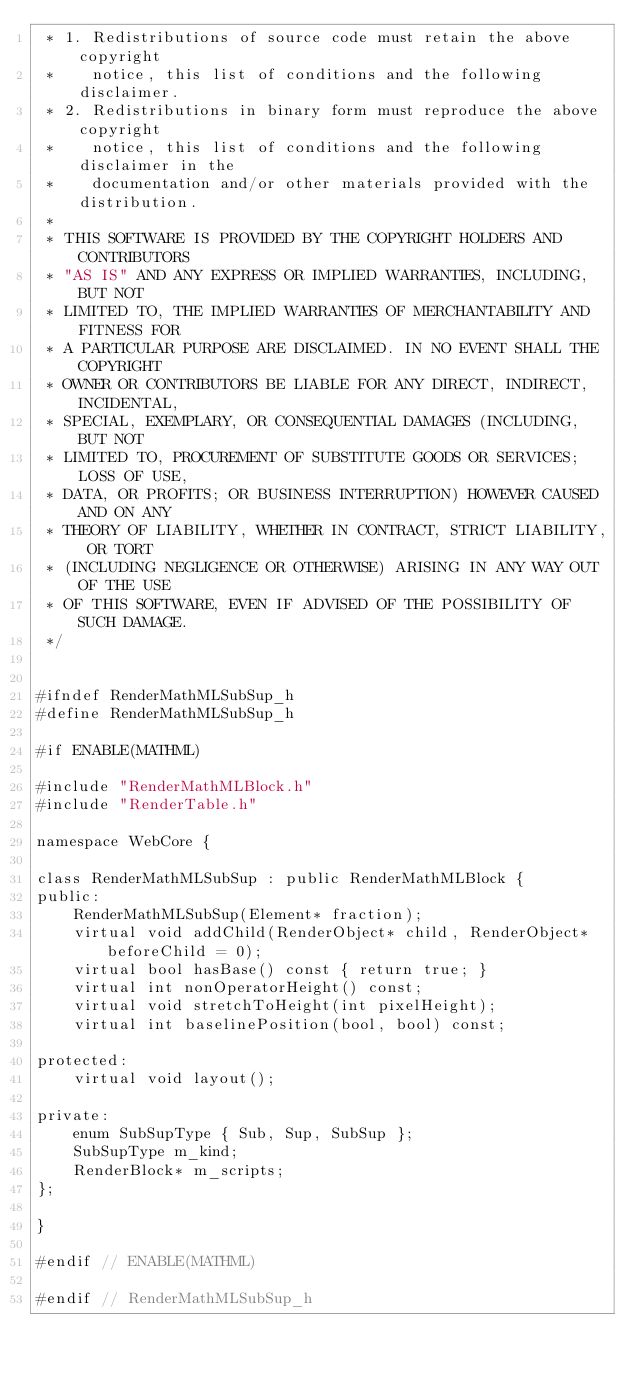Convert code to text. <code><loc_0><loc_0><loc_500><loc_500><_C_> * 1. Redistributions of source code must retain the above copyright
 *    notice, this list of conditions and the following disclaimer.
 * 2. Redistributions in binary form must reproduce the above copyright
 *    notice, this list of conditions and the following disclaimer in the
 *    documentation and/or other materials provided with the distribution.
 *
 * THIS SOFTWARE IS PROVIDED BY THE COPYRIGHT HOLDERS AND CONTRIBUTORS
 * "AS IS" AND ANY EXPRESS OR IMPLIED WARRANTIES, INCLUDING, BUT NOT
 * LIMITED TO, THE IMPLIED WARRANTIES OF MERCHANTABILITY AND FITNESS FOR
 * A PARTICULAR PURPOSE ARE DISCLAIMED. IN NO EVENT SHALL THE COPYRIGHT
 * OWNER OR CONTRIBUTORS BE LIABLE FOR ANY DIRECT, INDIRECT, INCIDENTAL,
 * SPECIAL, EXEMPLARY, OR CONSEQUENTIAL DAMAGES (INCLUDING, BUT NOT
 * LIMITED TO, PROCUREMENT OF SUBSTITUTE GOODS OR SERVICES; LOSS OF USE,
 * DATA, OR PROFITS; OR BUSINESS INTERRUPTION) HOWEVER CAUSED AND ON ANY
 * THEORY OF LIABILITY, WHETHER IN CONTRACT, STRICT LIABILITY, OR TORT
 * (INCLUDING NEGLIGENCE OR OTHERWISE) ARISING IN ANY WAY OUT OF THE USE
 * OF THIS SOFTWARE, EVEN IF ADVISED OF THE POSSIBILITY OF SUCH DAMAGE.
 */


#ifndef RenderMathMLSubSup_h
#define RenderMathMLSubSup_h

#if ENABLE(MATHML)

#include "RenderMathMLBlock.h"
#include "RenderTable.h"

namespace WebCore {
    
class RenderMathMLSubSup : public RenderMathMLBlock {
public:
    RenderMathMLSubSup(Element* fraction);
    virtual void addChild(RenderObject* child, RenderObject* beforeChild = 0);
    virtual bool hasBase() const { return true; }
    virtual int nonOperatorHeight() const;
    virtual void stretchToHeight(int pixelHeight);
    virtual int baselinePosition(bool, bool) const;    

protected:
    virtual void layout();
    
private:
    enum SubSupType { Sub, Sup, SubSup };
    SubSupType m_kind;
    RenderBlock* m_scripts;
};
    
}

#endif // ENABLE(MATHML)

#endif // RenderMathMLSubSup_h

</code> 